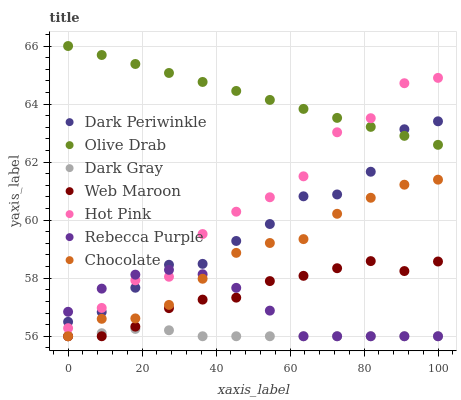Does Dark Gray have the minimum area under the curve?
Answer yes or no. Yes. Does Olive Drab have the maximum area under the curve?
Answer yes or no. Yes. Does Web Maroon have the minimum area under the curve?
Answer yes or no. No. Does Web Maroon have the maximum area under the curve?
Answer yes or no. No. Is Olive Drab the smoothest?
Answer yes or no. Yes. Is Hot Pink the roughest?
Answer yes or no. Yes. Is Web Maroon the smoothest?
Answer yes or no. No. Is Web Maroon the roughest?
Answer yes or no. No. Does Web Maroon have the lowest value?
Answer yes or no. Yes. Does Dark Periwinkle have the lowest value?
Answer yes or no. No. Does Olive Drab have the highest value?
Answer yes or no. Yes. Does Web Maroon have the highest value?
Answer yes or no. No. Is Chocolate less than Olive Drab?
Answer yes or no. Yes. Is Olive Drab greater than Dark Gray?
Answer yes or no. Yes. Does Dark Gray intersect Chocolate?
Answer yes or no. Yes. Is Dark Gray less than Chocolate?
Answer yes or no. No. Is Dark Gray greater than Chocolate?
Answer yes or no. No. Does Chocolate intersect Olive Drab?
Answer yes or no. No. 